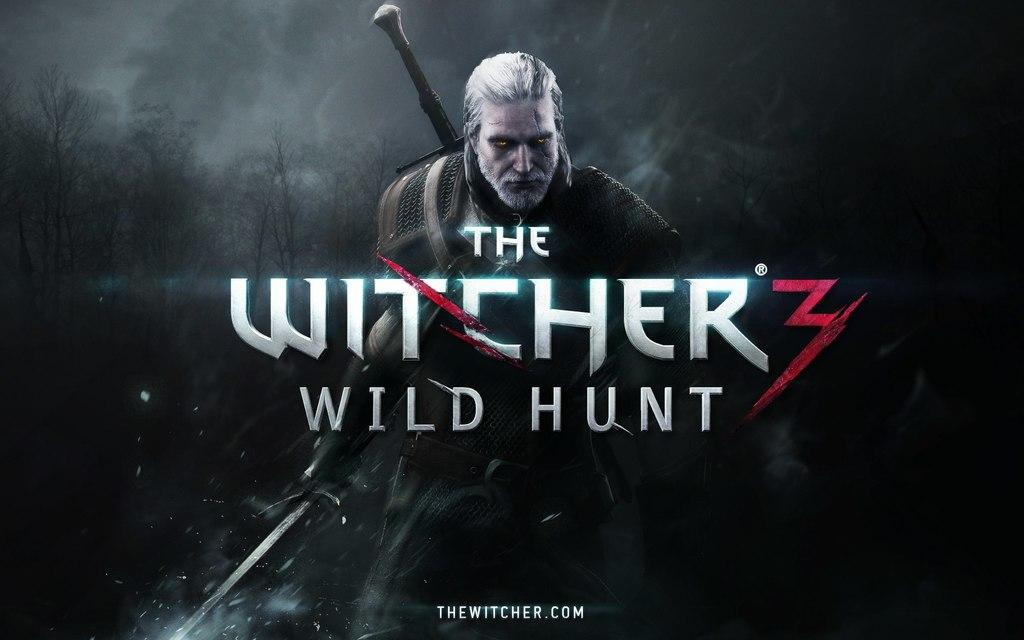<image>
Present a compact description of the photo's key features. A warrior holding a sword behind the words "The WItcher 3: Wild Hunt". 